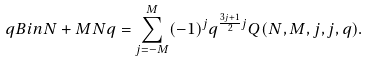Convert formula to latex. <formula><loc_0><loc_0><loc_500><loc_500>\ q B i n { N + M } { N } { q } = \sum _ { j = - M } ^ { M } ( - 1 ) ^ { j } q ^ { \frac { 3 j + 1 } { 2 } j } Q ( N , M , j , j , q ) .</formula> 